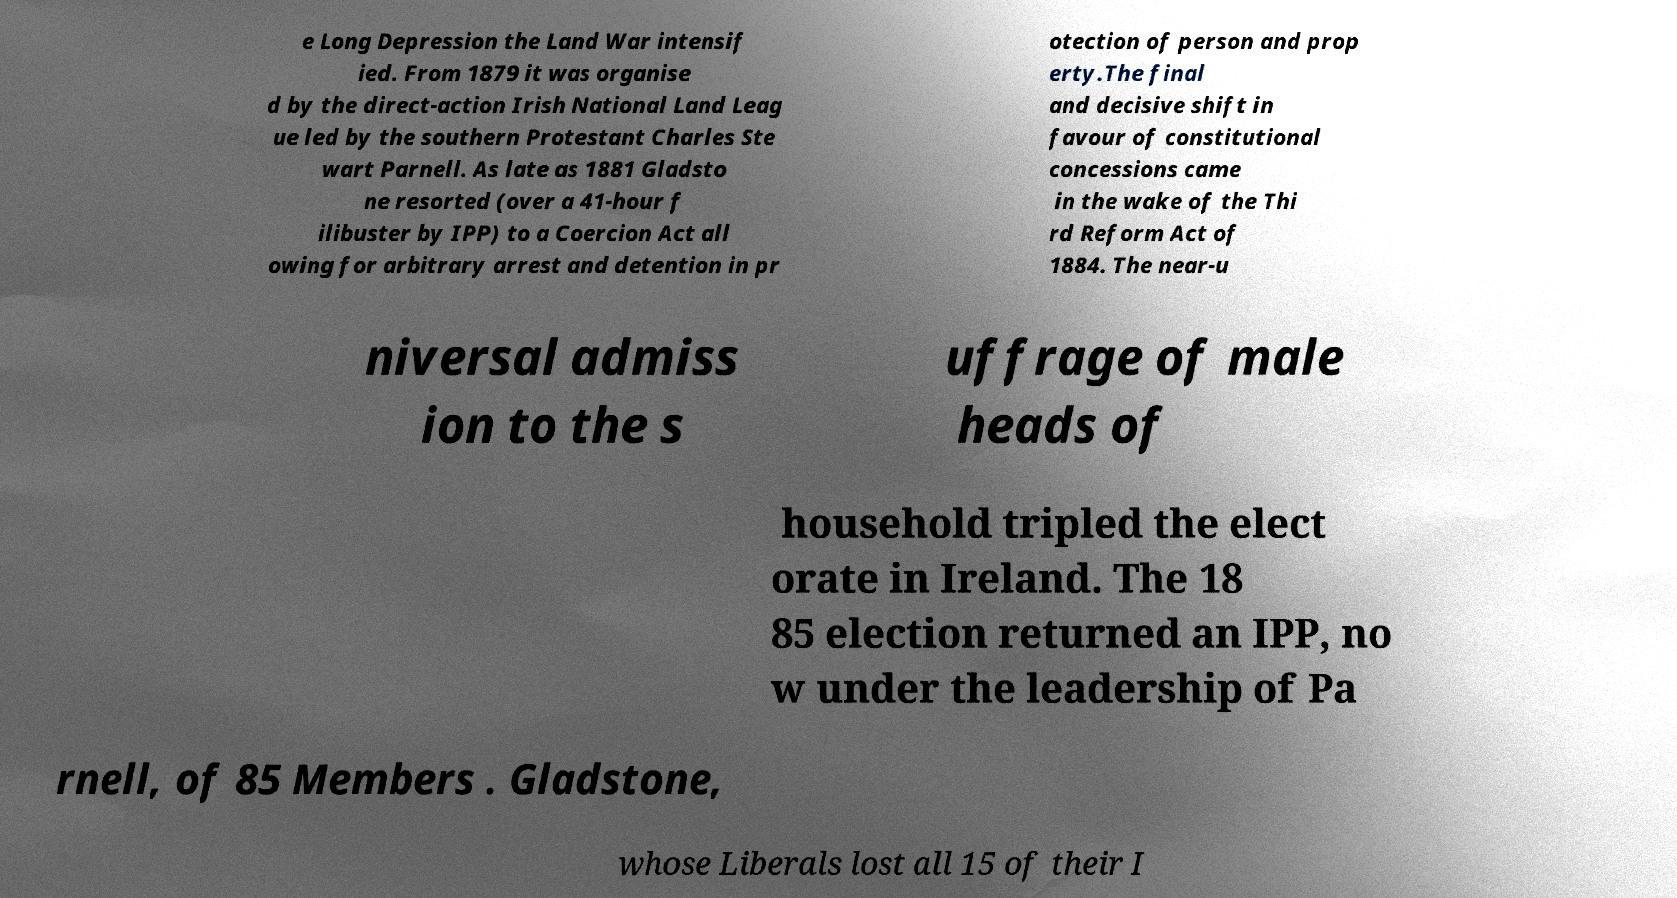There's text embedded in this image that I need extracted. Can you transcribe it verbatim? e Long Depression the Land War intensif ied. From 1879 it was organise d by the direct-action Irish National Land Leag ue led by the southern Protestant Charles Ste wart Parnell. As late as 1881 Gladsto ne resorted (over a 41-hour f ilibuster by IPP) to a Coercion Act all owing for arbitrary arrest and detention in pr otection of person and prop erty.The final and decisive shift in favour of constitutional concessions came in the wake of the Thi rd Reform Act of 1884. The near-u niversal admiss ion to the s uffrage of male heads of household tripled the elect orate in Ireland. The 18 85 election returned an IPP, no w under the leadership of Pa rnell, of 85 Members . Gladstone, whose Liberals lost all 15 of their I 